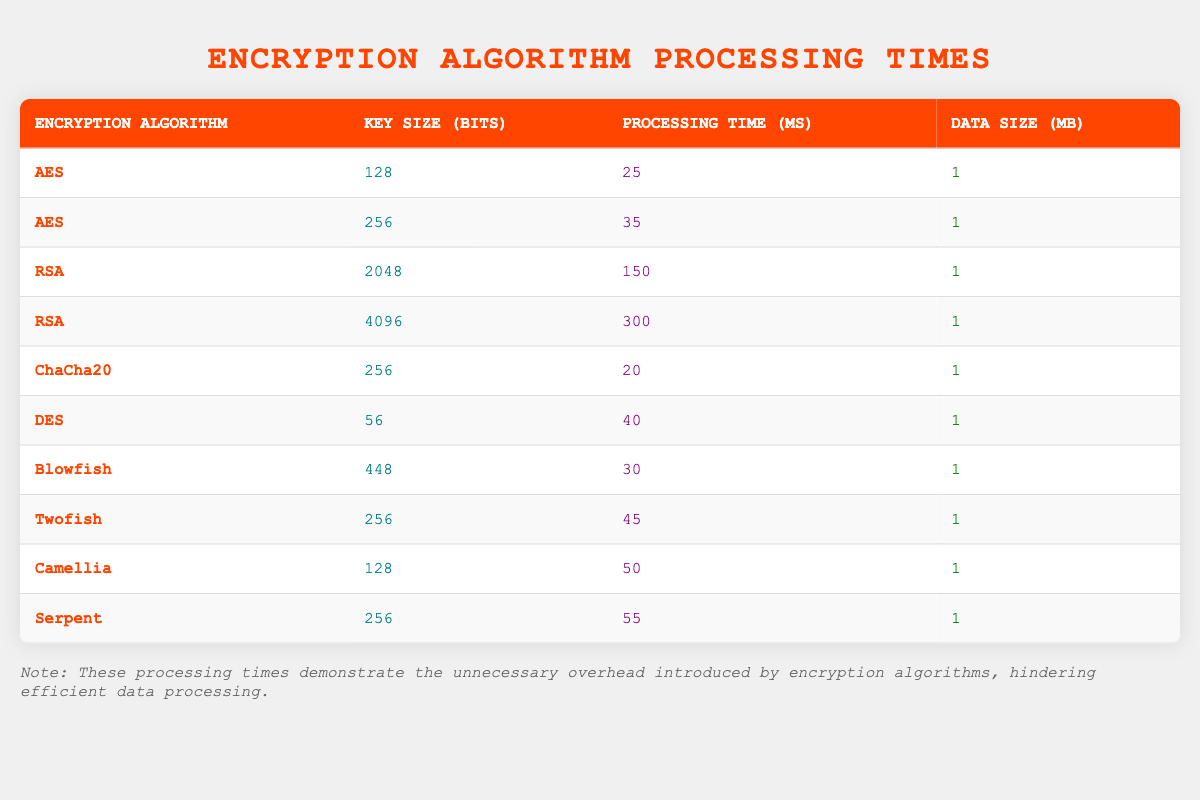What is the processing time for AES with a key size of 128 bits? According to the table, the row for AES with a key size of 128 bits indicates a processing time of 25 milliseconds.
Answer: 25 ms What is the processing time for RSA with a key size of 2048 bits? The table shows that for RSA with a key size of 2048 bits, the processing time is 150 milliseconds.
Answer: 150 ms Which encryption algorithm has the shortest processing time? By reviewing the processing times in the table, ChaCha20 has the shortest processing time at 20 milliseconds.
Answer: ChaCha20 Is the processing time for Twofish greater than or equal to that of Blowfish? Looking at the processing times in the table, Twofish has a processing time of 45 milliseconds, while Blowfish has a processing time of 30 milliseconds. Therefore, Twofish's time is greater than Blowfish's time.
Answer: Yes What is the average processing time for all encryption algorithms listed in the table? To find the average, we add up all processing times: (25 + 35 + 150 + 300 + 20 + 40 + 30 + 45 + 50 + 55) =  830 milliseconds. There are 10 algorithms, so the average is 830 / 10 = 83 milliseconds.
Answer: 83 ms How many algorithms have a processing time greater than 50 ms? By examining the table, we see that only the following algorithms exceed 50 milliseconds: RSA with 150 ms, RSA with 300 ms, Camellia with 50 ms, Twofish with 45 ms, and Serpent with 55 ms. The ones above 50 ms are: RSA (both), Camellia, Serpent. This gives us a total of 4 algorithms.
Answer: 4 Which encryption algorithm with a key size of 256 bits has the longest processing time? Reviewing the table for 256-bit algorithms, the following are listed: AES at 35 ms, ChaCha20 at 20 ms, Twofish at 45 ms, and Serpent at 55 ms. The longest processing time among these is Serpent at 55 milliseconds.
Answer: Serpent Is the processing time of AES with a key size of 256 bits less than that of DES? According to the data, the processing time for AES with a key size of 256 bits is 35 milliseconds, while DES has a processing time of 40 milliseconds. Hence, AES's time is less than DES's time.
Answer: Yes If we combine the processing times for both RSA algorithms, what is their total? The processing times for RSA are 150 ms for 2048 bits and 300 ms for 4096 bits. Adding these gives a total of 150 + 300 = 450 milliseconds.
Answer: 450 ms 